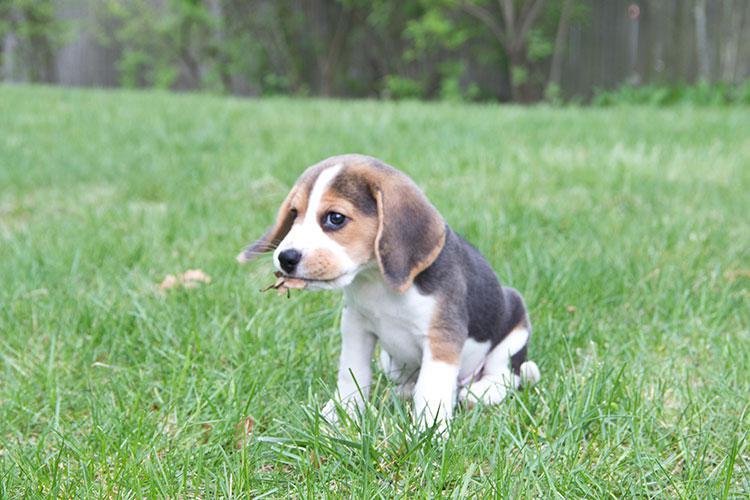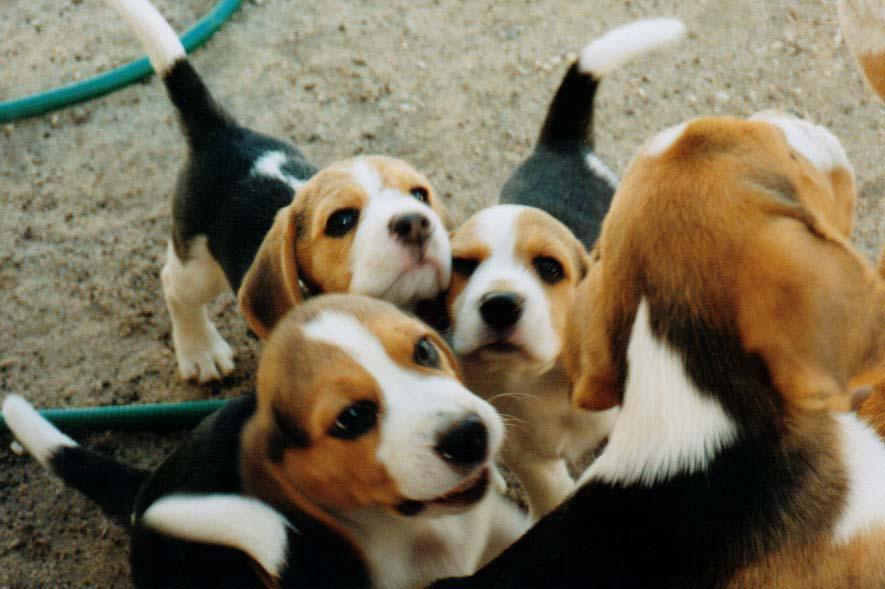The first image is the image on the left, the second image is the image on the right. For the images displayed, is the sentence "An equal number of puppies are shown in each image at an outdoor location, one of them with its front paws in mid- air." factually correct? Answer yes or no. No. The first image is the image on the left, the second image is the image on the right. Evaluate the accuracy of this statement regarding the images: "There are equal amount of dogs in the left image as the right.". Is it true? Answer yes or no. No. 